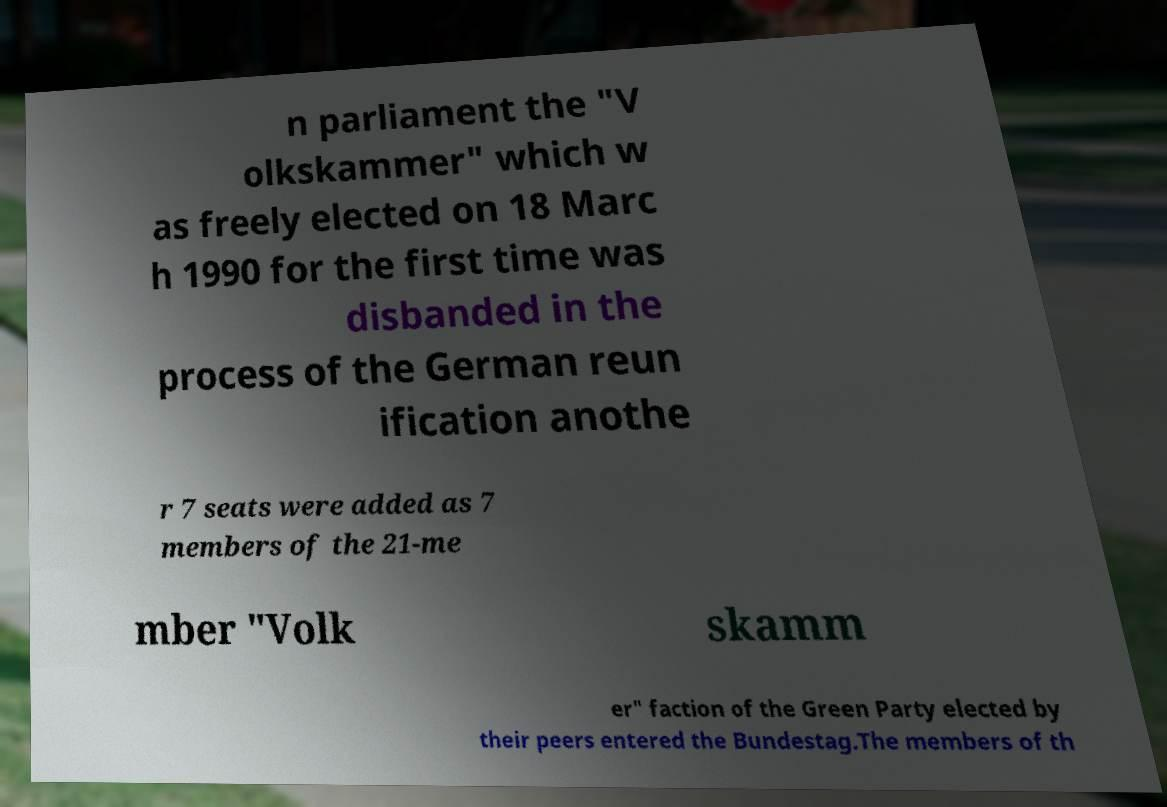Could you extract and type out the text from this image? n parliament the "V olkskammer" which w as freely elected on 18 Marc h 1990 for the first time was disbanded in the process of the German reun ification anothe r 7 seats were added as 7 members of the 21-me mber "Volk skamm er" faction of the Green Party elected by their peers entered the Bundestag.The members of th 